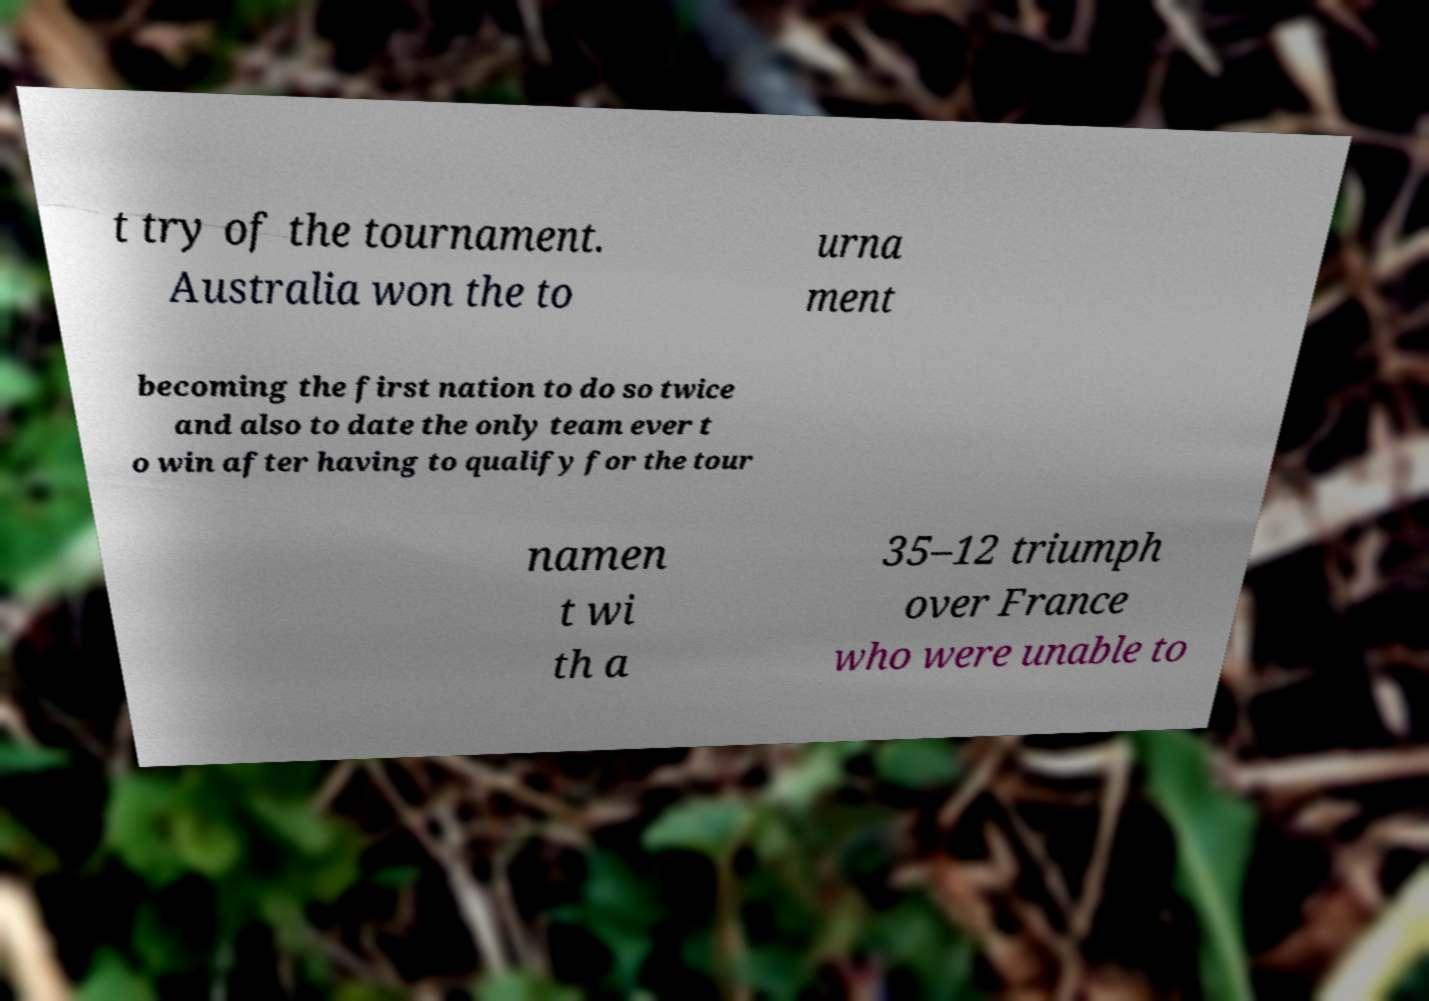For documentation purposes, I need the text within this image transcribed. Could you provide that? t try of the tournament. Australia won the to urna ment becoming the first nation to do so twice and also to date the only team ever t o win after having to qualify for the tour namen t wi th a 35–12 triumph over France who were unable to 